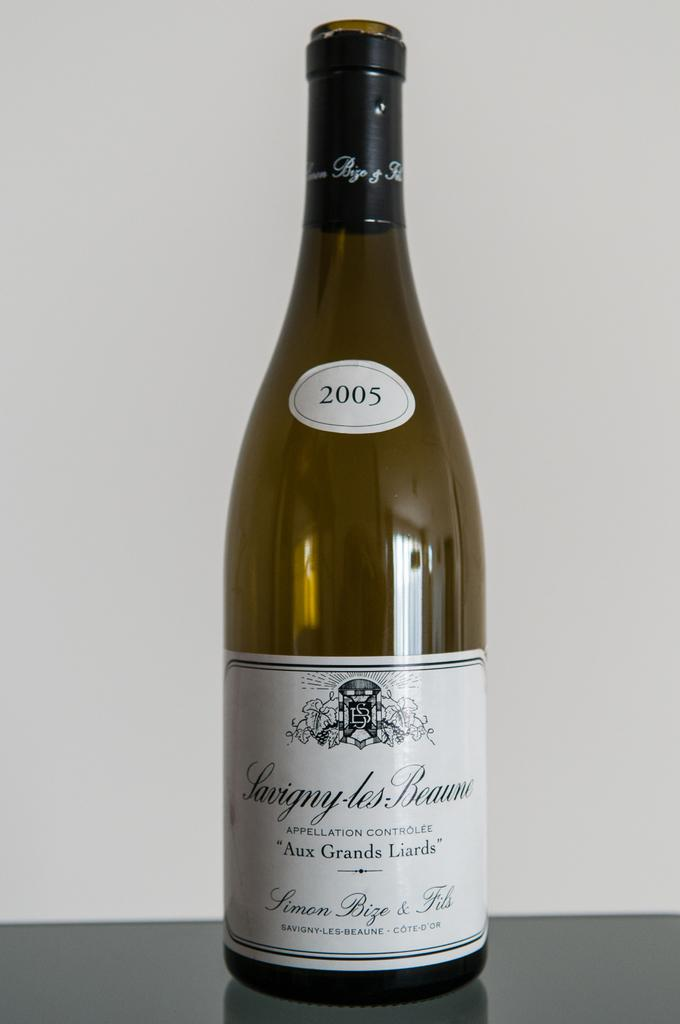<image>
Describe the image concisely. A bottle of French wine with a sticker of the year 2005 labeled on it. 